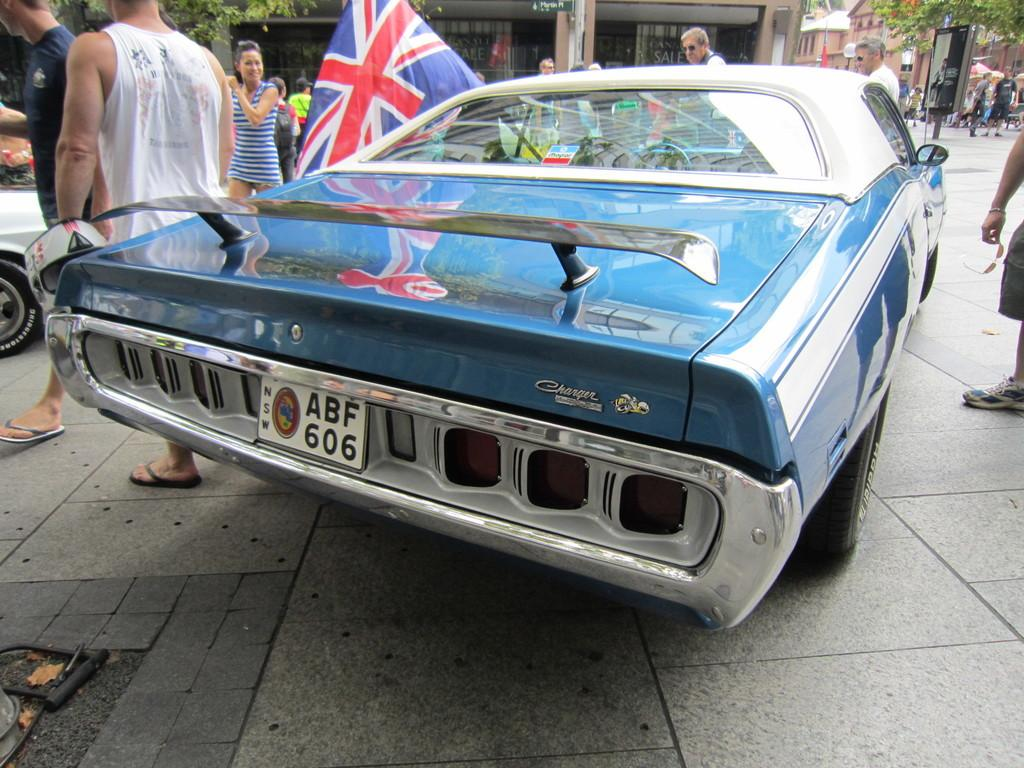<image>
Create a compact narrative representing the image presented. A classic, blue Charger with license plate ABF606 has a European flag hanging out of the drivers window. 